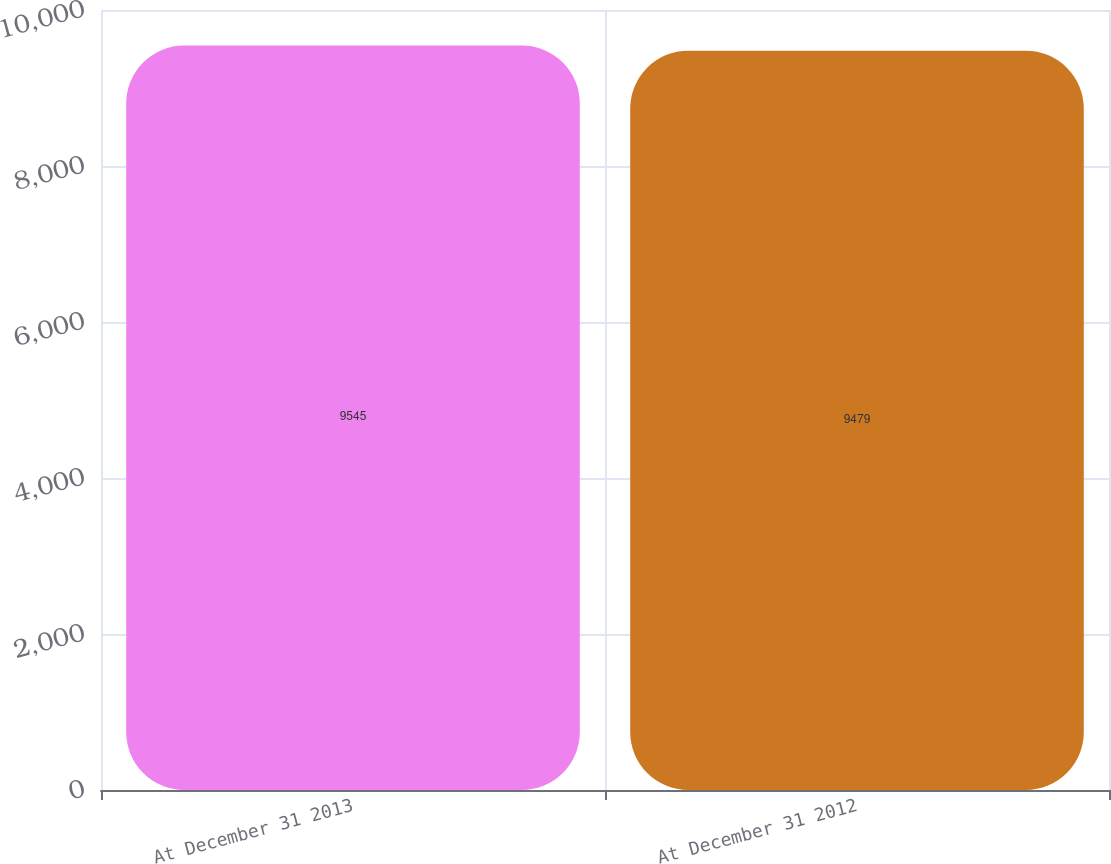<chart> <loc_0><loc_0><loc_500><loc_500><bar_chart><fcel>At December 31 2013<fcel>At December 31 2012<nl><fcel>9545<fcel>9479<nl></chart> 